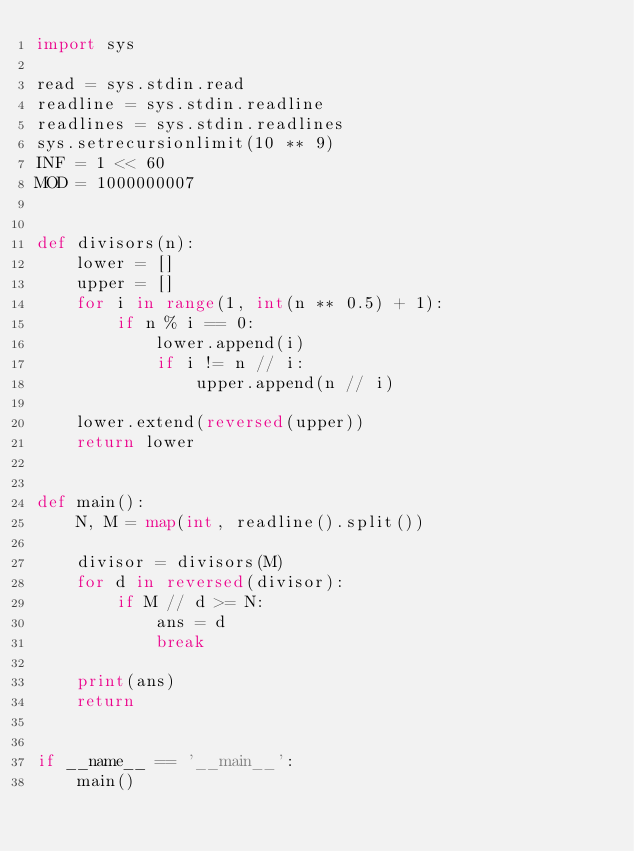<code> <loc_0><loc_0><loc_500><loc_500><_Python_>import sys

read = sys.stdin.read
readline = sys.stdin.readline
readlines = sys.stdin.readlines
sys.setrecursionlimit(10 ** 9)
INF = 1 << 60
MOD = 1000000007


def divisors(n):
    lower = []
    upper = []
    for i in range(1, int(n ** 0.5) + 1):
        if n % i == 0:
            lower.append(i)
            if i != n // i:
                upper.append(n // i)

    lower.extend(reversed(upper))
    return lower


def main():
    N, M = map(int, readline().split())

    divisor = divisors(M)
    for d in reversed(divisor):
        if M // d >= N:
            ans = d
            break

    print(ans)
    return


if __name__ == '__main__':
    main()
</code> 